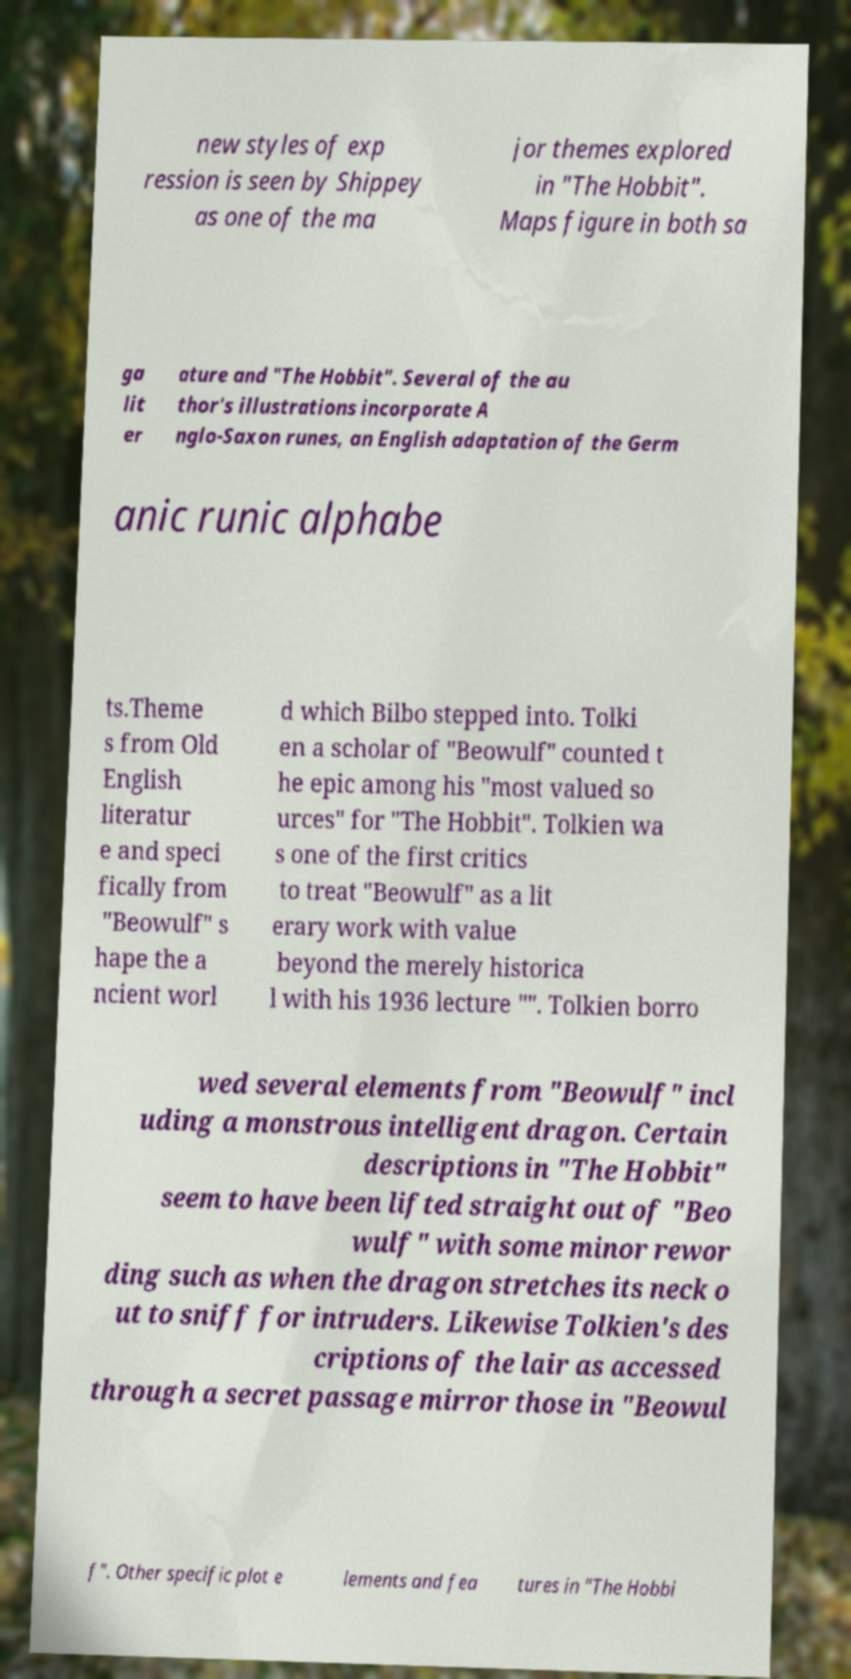Could you extract and type out the text from this image? new styles of exp ression is seen by Shippey as one of the ma jor themes explored in "The Hobbit". Maps figure in both sa ga lit er ature and "The Hobbit". Several of the au thor's illustrations incorporate A nglo-Saxon runes, an English adaptation of the Germ anic runic alphabe ts.Theme s from Old English literatur e and speci fically from "Beowulf" s hape the a ncient worl d which Bilbo stepped into. Tolki en a scholar of "Beowulf" counted t he epic among his "most valued so urces" for "The Hobbit". Tolkien wa s one of the first critics to treat "Beowulf" as a lit erary work with value beyond the merely historica l with his 1936 lecture "". Tolkien borro wed several elements from "Beowulf" incl uding a monstrous intelligent dragon. Certain descriptions in "The Hobbit" seem to have been lifted straight out of "Beo wulf" with some minor rewor ding such as when the dragon stretches its neck o ut to sniff for intruders. Likewise Tolkien's des criptions of the lair as accessed through a secret passage mirror those in "Beowul f". Other specific plot e lements and fea tures in "The Hobbi 